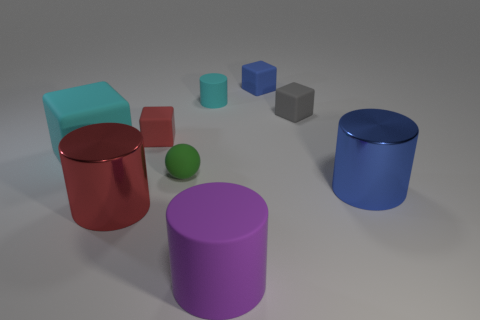Add 1 cyan spheres. How many objects exist? 10 Subtract all cubes. How many objects are left? 5 Add 9 purple matte cylinders. How many purple matte cylinders exist? 10 Subtract 1 red cylinders. How many objects are left? 8 Subtract all blue things. Subtract all blue objects. How many objects are left? 5 Add 7 tiny gray matte cubes. How many tiny gray matte cubes are left? 8 